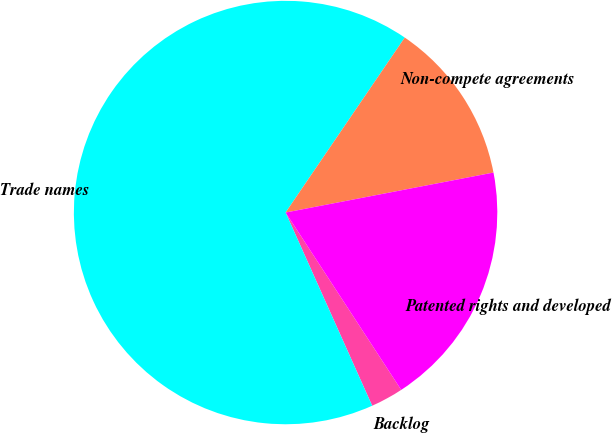<chart> <loc_0><loc_0><loc_500><loc_500><pie_chart><fcel>Backlog<fcel>Trade names<fcel>Non-compete agreements<fcel>Patented rights and developed<nl><fcel>2.49%<fcel>66.22%<fcel>12.46%<fcel>18.83%<nl></chart> 